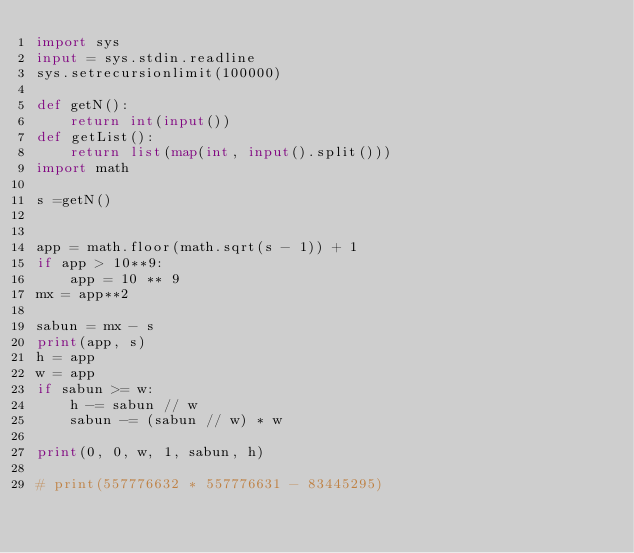Convert code to text. <code><loc_0><loc_0><loc_500><loc_500><_Python_>import sys
input = sys.stdin.readline
sys.setrecursionlimit(100000)

def getN():
    return int(input())
def getList():
    return list(map(int, input().split()))
import math

s =getN()


app = math.floor(math.sqrt(s - 1)) + 1
if app > 10**9:
    app = 10 ** 9
mx = app**2

sabun = mx - s
print(app, s)
h = app
w = app
if sabun >= w:
    h -= sabun // w
    sabun -= (sabun // w) * w

print(0, 0, w, 1, sabun, h)

# print(557776632 * 557776631 - 83445295)</code> 